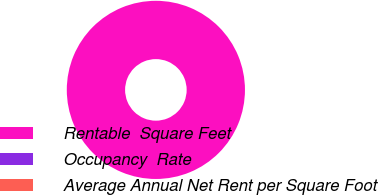<chart> <loc_0><loc_0><loc_500><loc_500><pie_chart><fcel>Rentable  Square Feet<fcel>Occupancy  Rate<fcel>Average Annual Net Rent per Square Foot<nl><fcel>100.0%<fcel>0.0%<fcel>0.0%<nl></chart> 